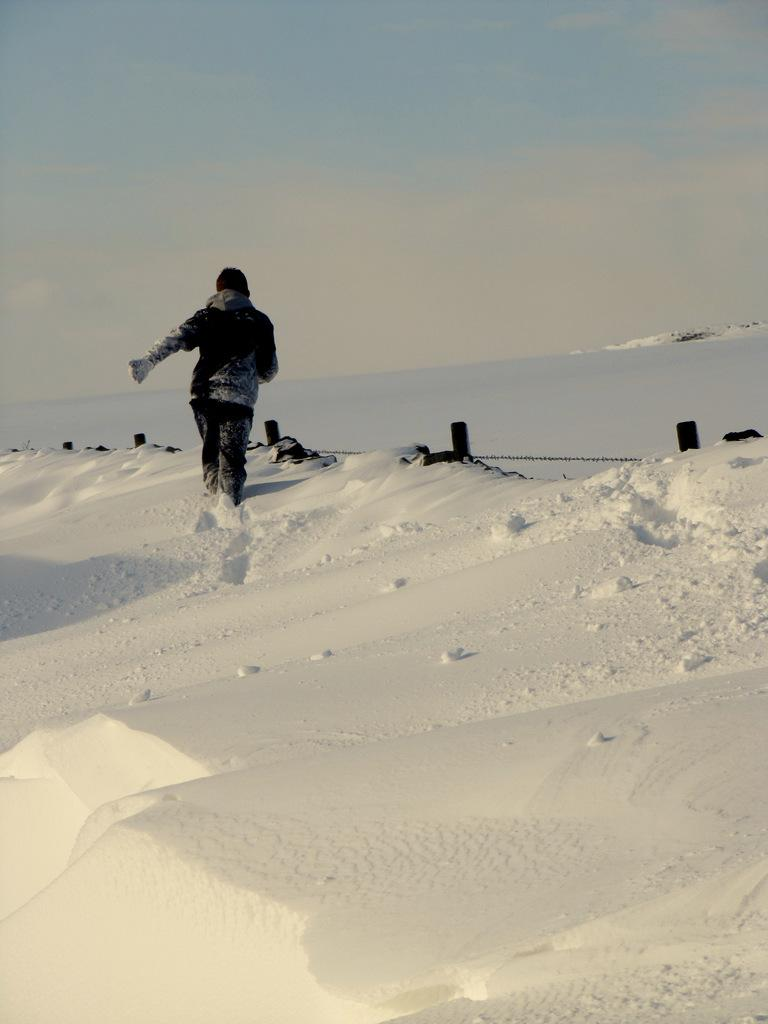Who is present in the image? There is a man in the image. What is the man doing in the image? The man is walking on the snow. What can be seen in the background of the image? The sky is visible in the background of the image. What is the terrain like in the image? The terrain is snowy, as the man is walking on the snow. What type of linen is being used to cover the man's face in the image? There is no linen or any object covering the man's face in the image. What disease is the man suffering from in the image? There is no indication of any disease in the image. 